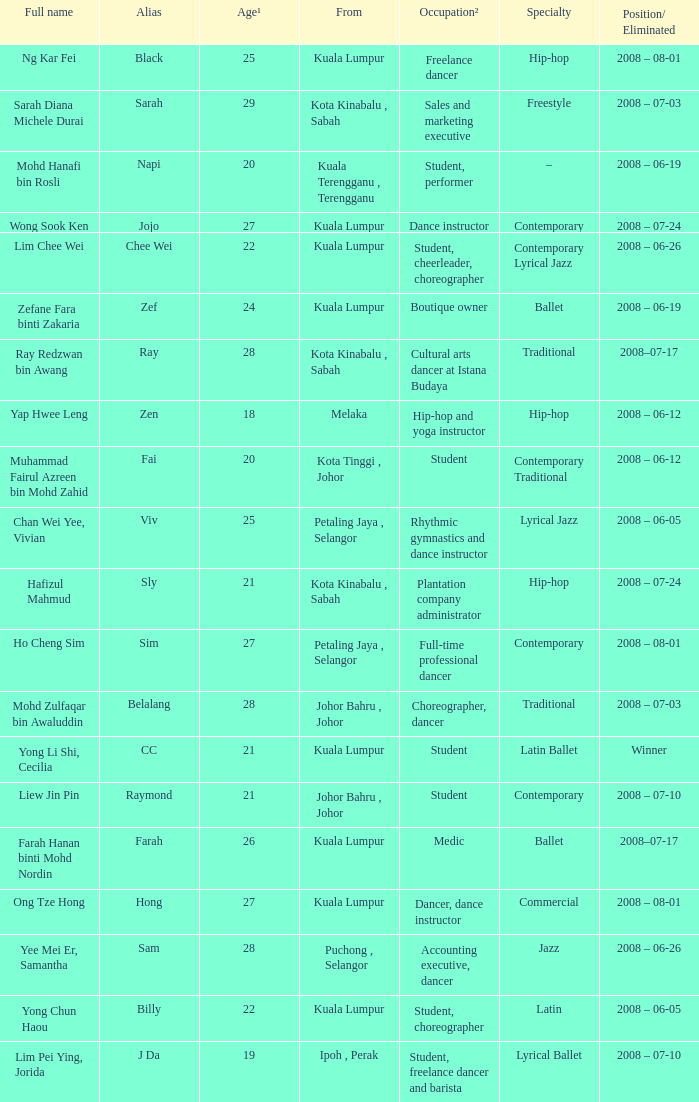What is Position/ Eliminated, when Age¹ is less than 22, and when Full Name is "Muhammad Fairul Azreen Bin Mohd Zahid"? 2008 – 06-12. 